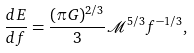<formula> <loc_0><loc_0><loc_500><loc_500>\frac { d E } { d f } = \frac { ( \pi G ) ^ { 2 / 3 } } { 3 } \mathcal { M } ^ { 5 / 3 } f ^ { - 1 / 3 } ,</formula> 